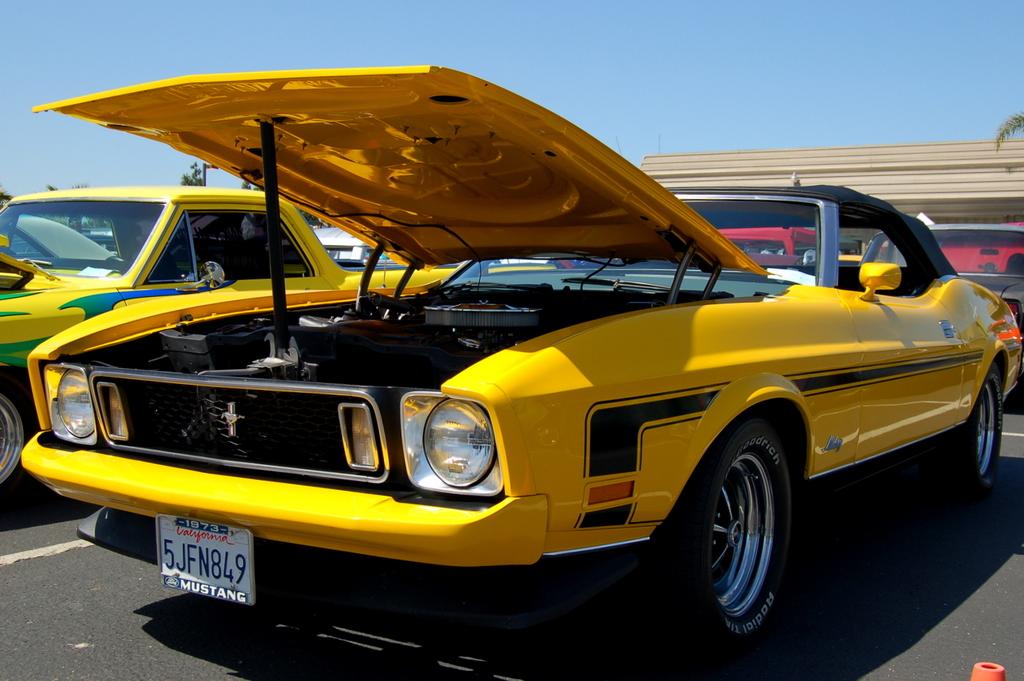What does the license plate say?
Offer a terse response. 5jfn849. What state is the license plate?
Offer a terse response. California. 